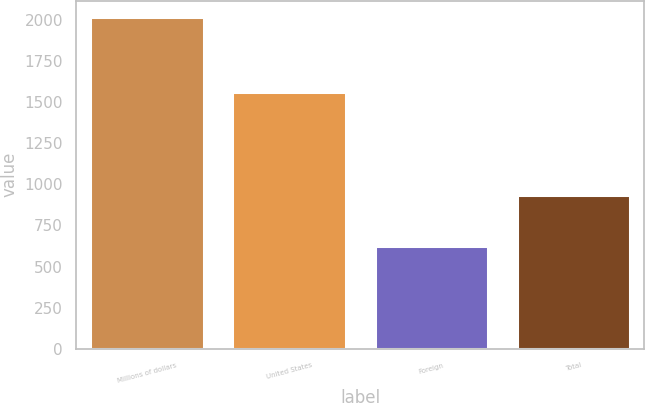<chart> <loc_0><loc_0><loc_500><loc_500><bar_chart><fcel>Millions of dollars<fcel>United States<fcel>Foreign<fcel>Total<nl><fcel>2015<fcel>1560<fcel>624<fcel>936<nl></chart> 